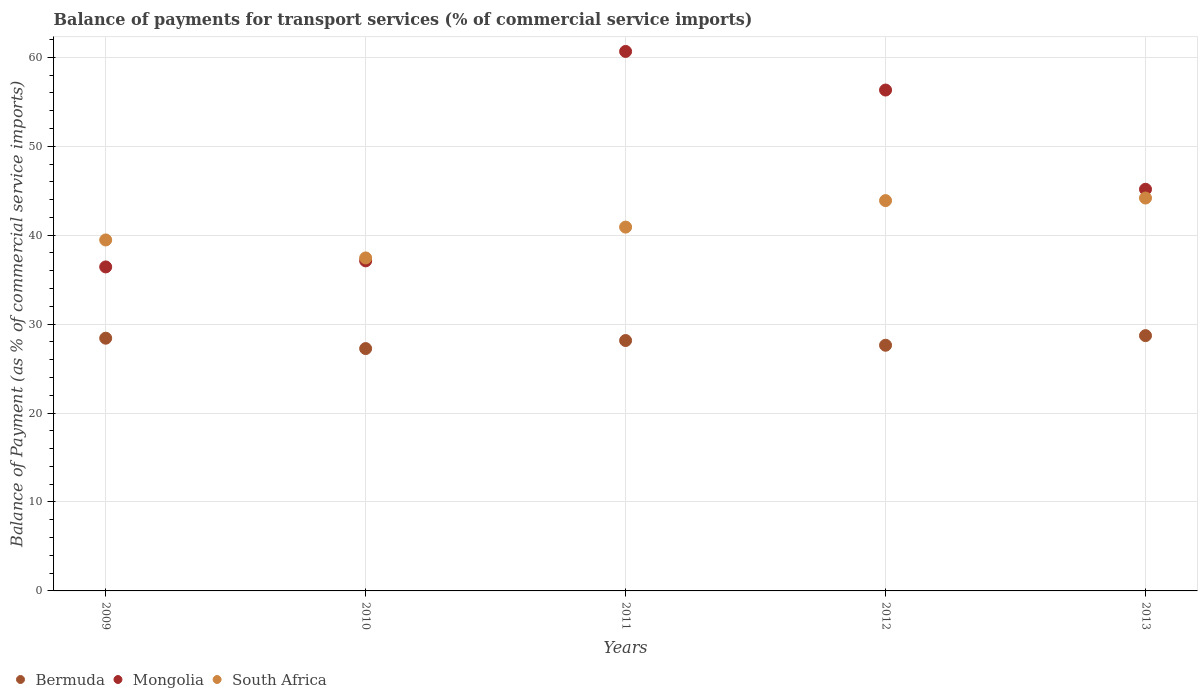How many different coloured dotlines are there?
Ensure brevity in your answer.  3. Is the number of dotlines equal to the number of legend labels?
Provide a short and direct response. Yes. What is the balance of payments for transport services in Mongolia in 2011?
Your response must be concise. 60.66. Across all years, what is the maximum balance of payments for transport services in Mongolia?
Your answer should be compact. 60.66. Across all years, what is the minimum balance of payments for transport services in South Africa?
Your answer should be compact. 37.44. In which year was the balance of payments for transport services in Mongolia minimum?
Your response must be concise. 2009. What is the total balance of payments for transport services in Bermuda in the graph?
Make the answer very short. 140.14. What is the difference between the balance of payments for transport services in South Africa in 2009 and that in 2011?
Offer a terse response. -1.44. What is the difference between the balance of payments for transport services in Mongolia in 2013 and the balance of payments for transport services in Bermuda in 2009?
Offer a terse response. 16.75. What is the average balance of payments for transport services in Mongolia per year?
Provide a short and direct response. 47.14. In the year 2010, what is the difference between the balance of payments for transport services in Bermuda and balance of payments for transport services in Mongolia?
Offer a very short reply. -9.86. What is the ratio of the balance of payments for transport services in Mongolia in 2010 to that in 2012?
Make the answer very short. 0.66. Is the balance of payments for transport services in Bermuda in 2009 less than that in 2010?
Your answer should be very brief. No. What is the difference between the highest and the second highest balance of payments for transport services in Mongolia?
Provide a succinct answer. 4.34. What is the difference between the highest and the lowest balance of payments for transport services in Mongolia?
Provide a short and direct response. 24.23. In how many years, is the balance of payments for transport services in Mongolia greater than the average balance of payments for transport services in Mongolia taken over all years?
Make the answer very short. 2. Is the sum of the balance of payments for transport services in Mongolia in 2010 and 2011 greater than the maximum balance of payments for transport services in Bermuda across all years?
Provide a succinct answer. Yes. Is it the case that in every year, the sum of the balance of payments for transport services in Mongolia and balance of payments for transport services in Bermuda  is greater than the balance of payments for transport services in South Africa?
Ensure brevity in your answer.  Yes. Does the balance of payments for transport services in Mongolia monotonically increase over the years?
Keep it short and to the point. No. Is the balance of payments for transport services in South Africa strictly greater than the balance of payments for transport services in Mongolia over the years?
Your answer should be very brief. No. How many years are there in the graph?
Your response must be concise. 5. What is the difference between two consecutive major ticks on the Y-axis?
Offer a terse response. 10. Are the values on the major ticks of Y-axis written in scientific E-notation?
Provide a succinct answer. No. Does the graph contain any zero values?
Keep it short and to the point. No. How are the legend labels stacked?
Your response must be concise. Horizontal. What is the title of the graph?
Keep it short and to the point. Balance of payments for transport services (% of commercial service imports). Does "Tonga" appear as one of the legend labels in the graph?
Your answer should be compact. No. What is the label or title of the X-axis?
Provide a short and direct response. Years. What is the label or title of the Y-axis?
Your response must be concise. Balance of Payment (as % of commercial service imports). What is the Balance of Payment (as % of commercial service imports) in Bermuda in 2009?
Offer a very short reply. 28.41. What is the Balance of Payment (as % of commercial service imports) in Mongolia in 2009?
Provide a short and direct response. 36.43. What is the Balance of Payment (as % of commercial service imports) in South Africa in 2009?
Your answer should be compact. 39.46. What is the Balance of Payment (as % of commercial service imports) in Bermuda in 2010?
Give a very brief answer. 27.25. What is the Balance of Payment (as % of commercial service imports) of Mongolia in 2010?
Ensure brevity in your answer.  37.11. What is the Balance of Payment (as % of commercial service imports) in South Africa in 2010?
Provide a short and direct response. 37.44. What is the Balance of Payment (as % of commercial service imports) of Bermuda in 2011?
Make the answer very short. 28.15. What is the Balance of Payment (as % of commercial service imports) in Mongolia in 2011?
Your response must be concise. 60.66. What is the Balance of Payment (as % of commercial service imports) of South Africa in 2011?
Give a very brief answer. 40.91. What is the Balance of Payment (as % of commercial service imports) in Bermuda in 2012?
Your response must be concise. 27.62. What is the Balance of Payment (as % of commercial service imports) of Mongolia in 2012?
Your response must be concise. 56.32. What is the Balance of Payment (as % of commercial service imports) in South Africa in 2012?
Your response must be concise. 43.88. What is the Balance of Payment (as % of commercial service imports) in Bermuda in 2013?
Offer a terse response. 28.7. What is the Balance of Payment (as % of commercial service imports) in Mongolia in 2013?
Your response must be concise. 45.16. What is the Balance of Payment (as % of commercial service imports) of South Africa in 2013?
Your answer should be compact. 44.17. Across all years, what is the maximum Balance of Payment (as % of commercial service imports) of Bermuda?
Make the answer very short. 28.7. Across all years, what is the maximum Balance of Payment (as % of commercial service imports) of Mongolia?
Offer a terse response. 60.66. Across all years, what is the maximum Balance of Payment (as % of commercial service imports) in South Africa?
Give a very brief answer. 44.17. Across all years, what is the minimum Balance of Payment (as % of commercial service imports) in Bermuda?
Make the answer very short. 27.25. Across all years, what is the minimum Balance of Payment (as % of commercial service imports) in Mongolia?
Your answer should be compact. 36.43. Across all years, what is the minimum Balance of Payment (as % of commercial service imports) of South Africa?
Keep it short and to the point. 37.44. What is the total Balance of Payment (as % of commercial service imports) in Bermuda in the graph?
Offer a terse response. 140.14. What is the total Balance of Payment (as % of commercial service imports) in Mongolia in the graph?
Keep it short and to the point. 235.68. What is the total Balance of Payment (as % of commercial service imports) of South Africa in the graph?
Offer a very short reply. 205.87. What is the difference between the Balance of Payment (as % of commercial service imports) in Bermuda in 2009 and that in 2010?
Offer a very short reply. 1.17. What is the difference between the Balance of Payment (as % of commercial service imports) in Mongolia in 2009 and that in 2010?
Give a very brief answer. -0.68. What is the difference between the Balance of Payment (as % of commercial service imports) of South Africa in 2009 and that in 2010?
Your answer should be very brief. 2.02. What is the difference between the Balance of Payment (as % of commercial service imports) of Bermuda in 2009 and that in 2011?
Ensure brevity in your answer.  0.26. What is the difference between the Balance of Payment (as % of commercial service imports) in Mongolia in 2009 and that in 2011?
Your answer should be compact. -24.23. What is the difference between the Balance of Payment (as % of commercial service imports) of South Africa in 2009 and that in 2011?
Ensure brevity in your answer.  -1.44. What is the difference between the Balance of Payment (as % of commercial service imports) in Bermuda in 2009 and that in 2012?
Your answer should be compact. 0.79. What is the difference between the Balance of Payment (as % of commercial service imports) in Mongolia in 2009 and that in 2012?
Keep it short and to the point. -19.89. What is the difference between the Balance of Payment (as % of commercial service imports) in South Africa in 2009 and that in 2012?
Make the answer very short. -4.42. What is the difference between the Balance of Payment (as % of commercial service imports) in Bermuda in 2009 and that in 2013?
Ensure brevity in your answer.  -0.29. What is the difference between the Balance of Payment (as % of commercial service imports) of Mongolia in 2009 and that in 2013?
Give a very brief answer. -8.73. What is the difference between the Balance of Payment (as % of commercial service imports) of South Africa in 2009 and that in 2013?
Your answer should be compact. -4.71. What is the difference between the Balance of Payment (as % of commercial service imports) of Bermuda in 2010 and that in 2011?
Ensure brevity in your answer.  -0.9. What is the difference between the Balance of Payment (as % of commercial service imports) of Mongolia in 2010 and that in 2011?
Your response must be concise. -23.55. What is the difference between the Balance of Payment (as % of commercial service imports) of South Africa in 2010 and that in 2011?
Offer a very short reply. -3.47. What is the difference between the Balance of Payment (as % of commercial service imports) in Bermuda in 2010 and that in 2012?
Your response must be concise. -0.37. What is the difference between the Balance of Payment (as % of commercial service imports) in Mongolia in 2010 and that in 2012?
Ensure brevity in your answer.  -19.21. What is the difference between the Balance of Payment (as % of commercial service imports) of South Africa in 2010 and that in 2012?
Ensure brevity in your answer.  -6.44. What is the difference between the Balance of Payment (as % of commercial service imports) of Bermuda in 2010 and that in 2013?
Your answer should be very brief. -1.45. What is the difference between the Balance of Payment (as % of commercial service imports) in Mongolia in 2010 and that in 2013?
Provide a short and direct response. -8.05. What is the difference between the Balance of Payment (as % of commercial service imports) of South Africa in 2010 and that in 2013?
Your answer should be very brief. -6.73. What is the difference between the Balance of Payment (as % of commercial service imports) in Bermuda in 2011 and that in 2012?
Your response must be concise. 0.53. What is the difference between the Balance of Payment (as % of commercial service imports) of Mongolia in 2011 and that in 2012?
Offer a very short reply. 4.34. What is the difference between the Balance of Payment (as % of commercial service imports) in South Africa in 2011 and that in 2012?
Provide a succinct answer. -2.98. What is the difference between the Balance of Payment (as % of commercial service imports) in Bermuda in 2011 and that in 2013?
Your answer should be very brief. -0.55. What is the difference between the Balance of Payment (as % of commercial service imports) in Mongolia in 2011 and that in 2013?
Your answer should be very brief. 15.5. What is the difference between the Balance of Payment (as % of commercial service imports) in South Africa in 2011 and that in 2013?
Ensure brevity in your answer.  -3.27. What is the difference between the Balance of Payment (as % of commercial service imports) of Bermuda in 2012 and that in 2013?
Give a very brief answer. -1.08. What is the difference between the Balance of Payment (as % of commercial service imports) in Mongolia in 2012 and that in 2013?
Offer a very short reply. 11.16. What is the difference between the Balance of Payment (as % of commercial service imports) in South Africa in 2012 and that in 2013?
Your answer should be very brief. -0.29. What is the difference between the Balance of Payment (as % of commercial service imports) in Bermuda in 2009 and the Balance of Payment (as % of commercial service imports) in Mongolia in 2010?
Ensure brevity in your answer.  -8.7. What is the difference between the Balance of Payment (as % of commercial service imports) of Bermuda in 2009 and the Balance of Payment (as % of commercial service imports) of South Africa in 2010?
Your answer should be very brief. -9.03. What is the difference between the Balance of Payment (as % of commercial service imports) of Mongolia in 2009 and the Balance of Payment (as % of commercial service imports) of South Africa in 2010?
Provide a succinct answer. -1.01. What is the difference between the Balance of Payment (as % of commercial service imports) of Bermuda in 2009 and the Balance of Payment (as % of commercial service imports) of Mongolia in 2011?
Offer a terse response. -32.24. What is the difference between the Balance of Payment (as % of commercial service imports) in Bermuda in 2009 and the Balance of Payment (as % of commercial service imports) in South Africa in 2011?
Give a very brief answer. -12.49. What is the difference between the Balance of Payment (as % of commercial service imports) in Mongolia in 2009 and the Balance of Payment (as % of commercial service imports) in South Africa in 2011?
Keep it short and to the point. -4.48. What is the difference between the Balance of Payment (as % of commercial service imports) of Bermuda in 2009 and the Balance of Payment (as % of commercial service imports) of Mongolia in 2012?
Provide a short and direct response. -27.9. What is the difference between the Balance of Payment (as % of commercial service imports) of Bermuda in 2009 and the Balance of Payment (as % of commercial service imports) of South Africa in 2012?
Give a very brief answer. -15.47. What is the difference between the Balance of Payment (as % of commercial service imports) of Mongolia in 2009 and the Balance of Payment (as % of commercial service imports) of South Africa in 2012?
Provide a short and direct response. -7.46. What is the difference between the Balance of Payment (as % of commercial service imports) in Bermuda in 2009 and the Balance of Payment (as % of commercial service imports) in Mongolia in 2013?
Give a very brief answer. -16.75. What is the difference between the Balance of Payment (as % of commercial service imports) in Bermuda in 2009 and the Balance of Payment (as % of commercial service imports) in South Africa in 2013?
Your response must be concise. -15.76. What is the difference between the Balance of Payment (as % of commercial service imports) in Mongolia in 2009 and the Balance of Payment (as % of commercial service imports) in South Africa in 2013?
Your answer should be very brief. -7.75. What is the difference between the Balance of Payment (as % of commercial service imports) of Bermuda in 2010 and the Balance of Payment (as % of commercial service imports) of Mongolia in 2011?
Make the answer very short. -33.41. What is the difference between the Balance of Payment (as % of commercial service imports) of Bermuda in 2010 and the Balance of Payment (as % of commercial service imports) of South Africa in 2011?
Keep it short and to the point. -13.66. What is the difference between the Balance of Payment (as % of commercial service imports) in Mongolia in 2010 and the Balance of Payment (as % of commercial service imports) in South Africa in 2011?
Provide a short and direct response. -3.79. What is the difference between the Balance of Payment (as % of commercial service imports) in Bermuda in 2010 and the Balance of Payment (as % of commercial service imports) in Mongolia in 2012?
Offer a very short reply. -29.07. What is the difference between the Balance of Payment (as % of commercial service imports) in Bermuda in 2010 and the Balance of Payment (as % of commercial service imports) in South Africa in 2012?
Offer a terse response. -16.64. What is the difference between the Balance of Payment (as % of commercial service imports) in Mongolia in 2010 and the Balance of Payment (as % of commercial service imports) in South Africa in 2012?
Make the answer very short. -6.77. What is the difference between the Balance of Payment (as % of commercial service imports) of Bermuda in 2010 and the Balance of Payment (as % of commercial service imports) of Mongolia in 2013?
Offer a very short reply. -17.91. What is the difference between the Balance of Payment (as % of commercial service imports) of Bermuda in 2010 and the Balance of Payment (as % of commercial service imports) of South Africa in 2013?
Offer a very short reply. -16.93. What is the difference between the Balance of Payment (as % of commercial service imports) in Mongolia in 2010 and the Balance of Payment (as % of commercial service imports) in South Africa in 2013?
Your answer should be very brief. -7.06. What is the difference between the Balance of Payment (as % of commercial service imports) of Bermuda in 2011 and the Balance of Payment (as % of commercial service imports) of Mongolia in 2012?
Offer a very short reply. -28.16. What is the difference between the Balance of Payment (as % of commercial service imports) in Bermuda in 2011 and the Balance of Payment (as % of commercial service imports) in South Africa in 2012?
Your response must be concise. -15.73. What is the difference between the Balance of Payment (as % of commercial service imports) in Mongolia in 2011 and the Balance of Payment (as % of commercial service imports) in South Africa in 2012?
Your answer should be compact. 16.77. What is the difference between the Balance of Payment (as % of commercial service imports) of Bermuda in 2011 and the Balance of Payment (as % of commercial service imports) of Mongolia in 2013?
Keep it short and to the point. -17.01. What is the difference between the Balance of Payment (as % of commercial service imports) of Bermuda in 2011 and the Balance of Payment (as % of commercial service imports) of South Africa in 2013?
Keep it short and to the point. -16.02. What is the difference between the Balance of Payment (as % of commercial service imports) in Mongolia in 2011 and the Balance of Payment (as % of commercial service imports) in South Africa in 2013?
Make the answer very short. 16.48. What is the difference between the Balance of Payment (as % of commercial service imports) in Bermuda in 2012 and the Balance of Payment (as % of commercial service imports) in Mongolia in 2013?
Offer a very short reply. -17.54. What is the difference between the Balance of Payment (as % of commercial service imports) in Bermuda in 2012 and the Balance of Payment (as % of commercial service imports) in South Africa in 2013?
Your answer should be compact. -16.55. What is the difference between the Balance of Payment (as % of commercial service imports) of Mongolia in 2012 and the Balance of Payment (as % of commercial service imports) of South Africa in 2013?
Make the answer very short. 12.14. What is the average Balance of Payment (as % of commercial service imports) of Bermuda per year?
Give a very brief answer. 28.03. What is the average Balance of Payment (as % of commercial service imports) in Mongolia per year?
Provide a short and direct response. 47.13. What is the average Balance of Payment (as % of commercial service imports) of South Africa per year?
Make the answer very short. 41.17. In the year 2009, what is the difference between the Balance of Payment (as % of commercial service imports) in Bermuda and Balance of Payment (as % of commercial service imports) in Mongolia?
Offer a very short reply. -8.01. In the year 2009, what is the difference between the Balance of Payment (as % of commercial service imports) in Bermuda and Balance of Payment (as % of commercial service imports) in South Africa?
Make the answer very short. -11.05. In the year 2009, what is the difference between the Balance of Payment (as % of commercial service imports) of Mongolia and Balance of Payment (as % of commercial service imports) of South Africa?
Your response must be concise. -3.03. In the year 2010, what is the difference between the Balance of Payment (as % of commercial service imports) of Bermuda and Balance of Payment (as % of commercial service imports) of Mongolia?
Offer a terse response. -9.86. In the year 2010, what is the difference between the Balance of Payment (as % of commercial service imports) of Bermuda and Balance of Payment (as % of commercial service imports) of South Africa?
Your answer should be very brief. -10.19. In the year 2010, what is the difference between the Balance of Payment (as % of commercial service imports) in Mongolia and Balance of Payment (as % of commercial service imports) in South Africa?
Provide a succinct answer. -0.33. In the year 2011, what is the difference between the Balance of Payment (as % of commercial service imports) in Bermuda and Balance of Payment (as % of commercial service imports) in Mongolia?
Your answer should be compact. -32.5. In the year 2011, what is the difference between the Balance of Payment (as % of commercial service imports) of Bermuda and Balance of Payment (as % of commercial service imports) of South Africa?
Make the answer very short. -12.75. In the year 2011, what is the difference between the Balance of Payment (as % of commercial service imports) of Mongolia and Balance of Payment (as % of commercial service imports) of South Africa?
Offer a very short reply. 19.75. In the year 2012, what is the difference between the Balance of Payment (as % of commercial service imports) of Bermuda and Balance of Payment (as % of commercial service imports) of Mongolia?
Offer a very short reply. -28.69. In the year 2012, what is the difference between the Balance of Payment (as % of commercial service imports) in Bermuda and Balance of Payment (as % of commercial service imports) in South Africa?
Your answer should be compact. -16.26. In the year 2012, what is the difference between the Balance of Payment (as % of commercial service imports) in Mongolia and Balance of Payment (as % of commercial service imports) in South Africa?
Make the answer very short. 12.43. In the year 2013, what is the difference between the Balance of Payment (as % of commercial service imports) of Bermuda and Balance of Payment (as % of commercial service imports) of Mongolia?
Make the answer very short. -16.46. In the year 2013, what is the difference between the Balance of Payment (as % of commercial service imports) of Bermuda and Balance of Payment (as % of commercial service imports) of South Africa?
Offer a very short reply. -15.47. In the year 2013, what is the difference between the Balance of Payment (as % of commercial service imports) in Mongolia and Balance of Payment (as % of commercial service imports) in South Africa?
Your answer should be very brief. 0.99. What is the ratio of the Balance of Payment (as % of commercial service imports) of Bermuda in 2009 to that in 2010?
Ensure brevity in your answer.  1.04. What is the ratio of the Balance of Payment (as % of commercial service imports) of Mongolia in 2009 to that in 2010?
Offer a terse response. 0.98. What is the ratio of the Balance of Payment (as % of commercial service imports) in South Africa in 2009 to that in 2010?
Your answer should be very brief. 1.05. What is the ratio of the Balance of Payment (as % of commercial service imports) of Bermuda in 2009 to that in 2011?
Provide a short and direct response. 1.01. What is the ratio of the Balance of Payment (as % of commercial service imports) in Mongolia in 2009 to that in 2011?
Make the answer very short. 0.6. What is the ratio of the Balance of Payment (as % of commercial service imports) of South Africa in 2009 to that in 2011?
Keep it short and to the point. 0.96. What is the ratio of the Balance of Payment (as % of commercial service imports) in Bermuda in 2009 to that in 2012?
Provide a short and direct response. 1.03. What is the ratio of the Balance of Payment (as % of commercial service imports) of Mongolia in 2009 to that in 2012?
Ensure brevity in your answer.  0.65. What is the ratio of the Balance of Payment (as % of commercial service imports) of South Africa in 2009 to that in 2012?
Make the answer very short. 0.9. What is the ratio of the Balance of Payment (as % of commercial service imports) of Mongolia in 2009 to that in 2013?
Give a very brief answer. 0.81. What is the ratio of the Balance of Payment (as % of commercial service imports) in South Africa in 2009 to that in 2013?
Make the answer very short. 0.89. What is the ratio of the Balance of Payment (as % of commercial service imports) in Bermuda in 2010 to that in 2011?
Your answer should be very brief. 0.97. What is the ratio of the Balance of Payment (as % of commercial service imports) of Mongolia in 2010 to that in 2011?
Your answer should be compact. 0.61. What is the ratio of the Balance of Payment (as % of commercial service imports) of South Africa in 2010 to that in 2011?
Keep it short and to the point. 0.92. What is the ratio of the Balance of Payment (as % of commercial service imports) of Bermuda in 2010 to that in 2012?
Keep it short and to the point. 0.99. What is the ratio of the Balance of Payment (as % of commercial service imports) of Mongolia in 2010 to that in 2012?
Provide a succinct answer. 0.66. What is the ratio of the Balance of Payment (as % of commercial service imports) in South Africa in 2010 to that in 2012?
Provide a short and direct response. 0.85. What is the ratio of the Balance of Payment (as % of commercial service imports) in Bermuda in 2010 to that in 2013?
Provide a short and direct response. 0.95. What is the ratio of the Balance of Payment (as % of commercial service imports) in Mongolia in 2010 to that in 2013?
Provide a short and direct response. 0.82. What is the ratio of the Balance of Payment (as % of commercial service imports) of South Africa in 2010 to that in 2013?
Your answer should be very brief. 0.85. What is the ratio of the Balance of Payment (as % of commercial service imports) in Bermuda in 2011 to that in 2012?
Ensure brevity in your answer.  1.02. What is the ratio of the Balance of Payment (as % of commercial service imports) of Mongolia in 2011 to that in 2012?
Your answer should be compact. 1.08. What is the ratio of the Balance of Payment (as % of commercial service imports) of South Africa in 2011 to that in 2012?
Your response must be concise. 0.93. What is the ratio of the Balance of Payment (as % of commercial service imports) in Bermuda in 2011 to that in 2013?
Give a very brief answer. 0.98. What is the ratio of the Balance of Payment (as % of commercial service imports) of Mongolia in 2011 to that in 2013?
Make the answer very short. 1.34. What is the ratio of the Balance of Payment (as % of commercial service imports) in South Africa in 2011 to that in 2013?
Ensure brevity in your answer.  0.93. What is the ratio of the Balance of Payment (as % of commercial service imports) of Bermuda in 2012 to that in 2013?
Provide a short and direct response. 0.96. What is the ratio of the Balance of Payment (as % of commercial service imports) in Mongolia in 2012 to that in 2013?
Offer a terse response. 1.25. What is the ratio of the Balance of Payment (as % of commercial service imports) in South Africa in 2012 to that in 2013?
Provide a short and direct response. 0.99. What is the difference between the highest and the second highest Balance of Payment (as % of commercial service imports) in Bermuda?
Your answer should be very brief. 0.29. What is the difference between the highest and the second highest Balance of Payment (as % of commercial service imports) in Mongolia?
Offer a terse response. 4.34. What is the difference between the highest and the second highest Balance of Payment (as % of commercial service imports) in South Africa?
Keep it short and to the point. 0.29. What is the difference between the highest and the lowest Balance of Payment (as % of commercial service imports) in Bermuda?
Make the answer very short. 1.45. What is the difference between the highest and the lowest Balance of Payment (as % of commercial service imports) in Mongolia?
Your response must be concise. 24.23. What is the difference between the highest and the lowest Balance of Payment (as % of commercial service imports) of South Africa?
Your answer should be very brief. 6.73. 